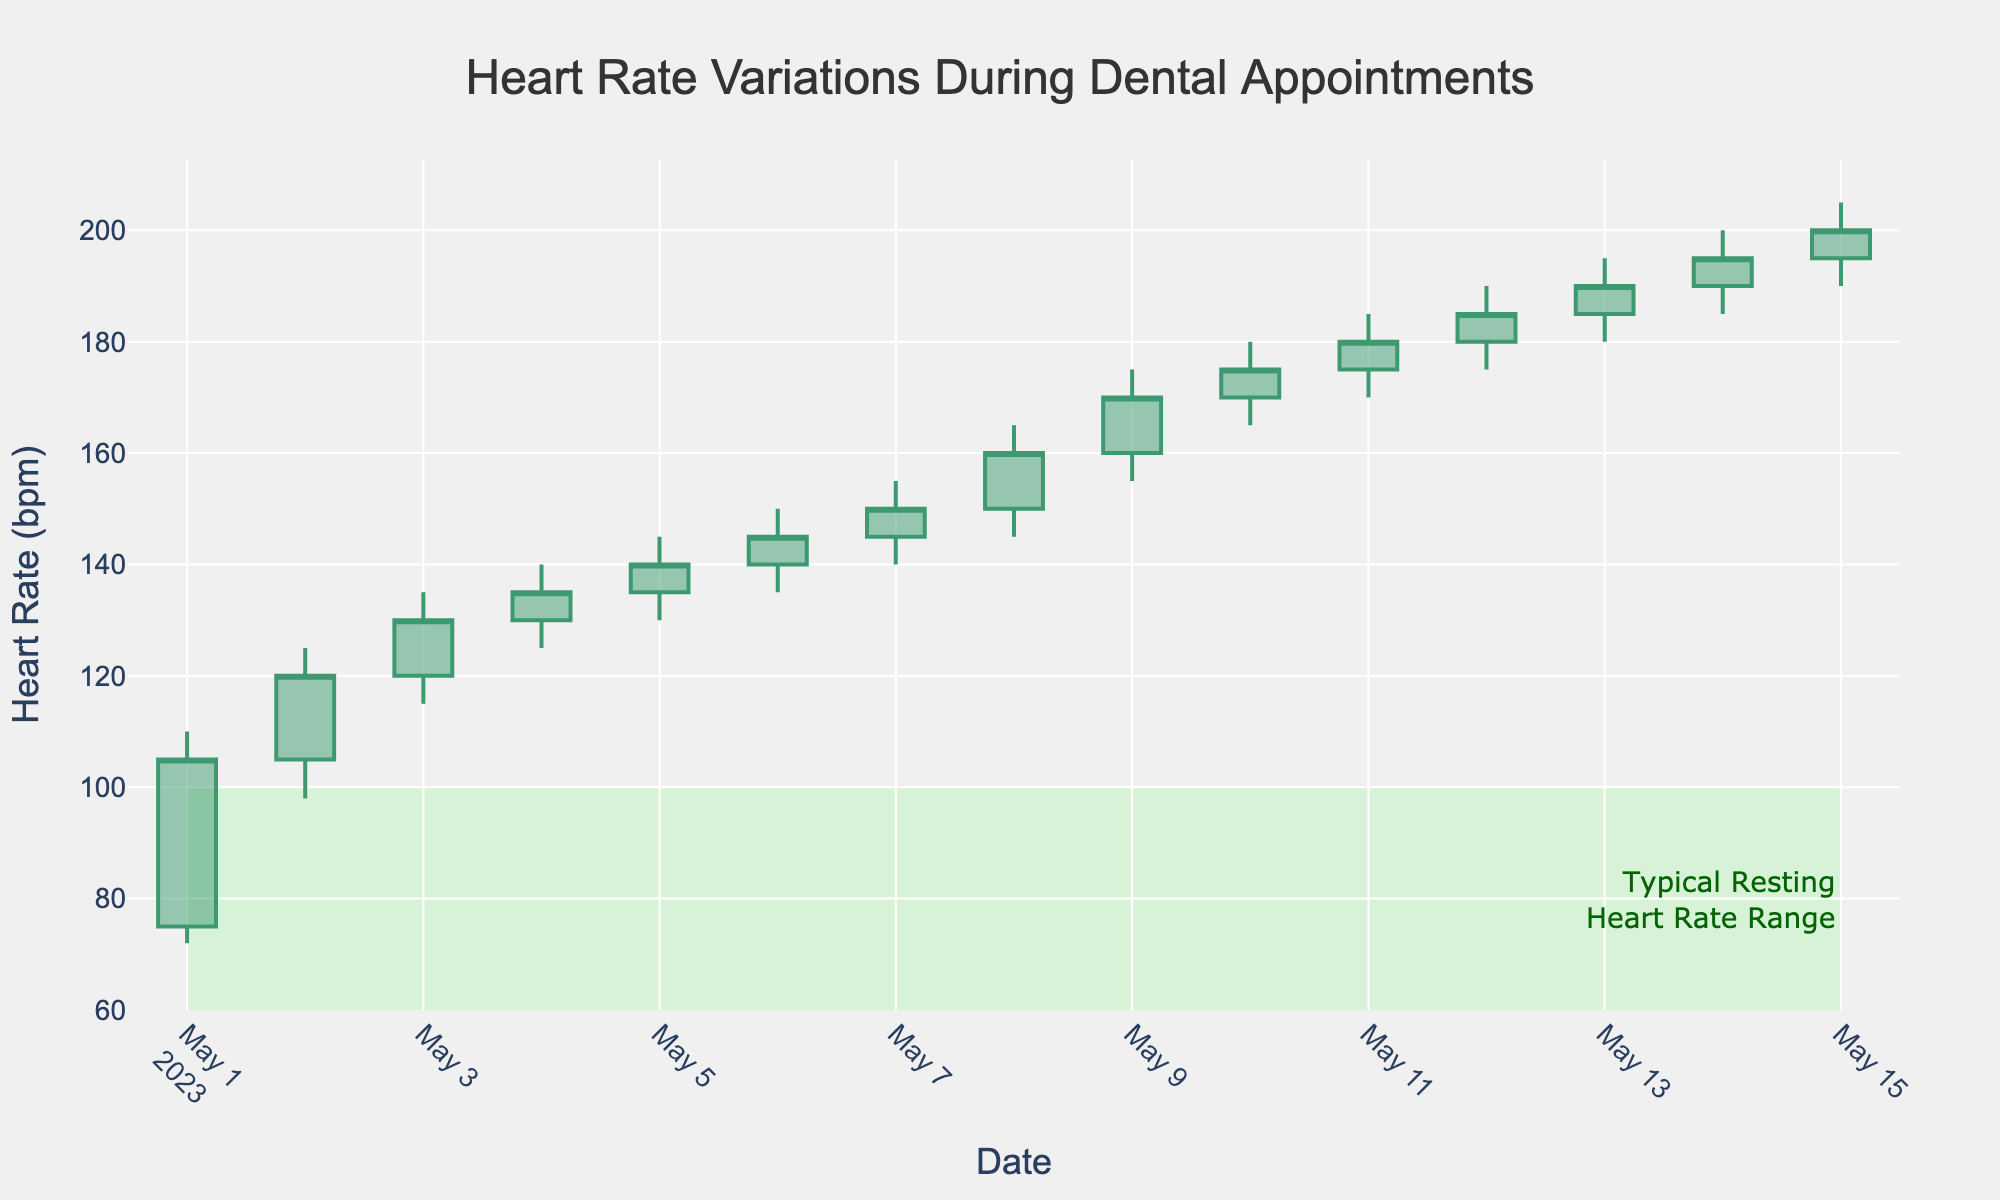What is the title of the chart? The title is prominently displayed at the top of the chart. It serves to inform the viewer of the data context.
Answer: Heart Rate Variations During Dental Appointments What is the range of dates shown on the x-axis? By examining the dates along the x-axis, we can observe the first and last dates on the chart.
Answer: 2023-05-01 to 2023-05-15 What is the highest heart rate recorded during the recorded time span? The highest point on the y-axis across all candlesticks represents the highest heart rate recorded. This appears as a peak reaching 205 bpm on 2023-05-15.
Answer: 205 bpm On which date was the patient’s heart rate first recorded above 100 bpm? By observing the candlestick data for each date, we determine the earliest date where the 'Open' value surpasses 100 bpm.
Answer: 2023-05-02 How much did the patient's heart rate rise from May 1 to May 15? First, identify the 'Open' value on 2023-05-01 (75 bpm) and the 'Close' value on 2023-05-15 (200 bpm), then calculate the difference. 200 bpm - 75 bpm equals 125 bpm.
Answer: 125 bpm Which dates mark the beginning and end of the annotated "Typical Resting Heart Rate Range"? The annotation specifies a resting heart rate range and starts on the first date and ends on the last date of the series.
Answer: 2023-05-01 to 2023-05-15 What was the lowest recorded heart rate and on what date did it occur? The lowest point on the y-axis across all candlesticks indicates the lowest recorded heart rate, observed on 2023-05-01 at 72 bpm.
Answer: 72 bpm on 2023-05-01 Which date has the smallest range between the high and low heart rate, and what is the range? Calculate the difference between 'High' and 'Low' for each day and find the day with the smallest difference. For 2023-05-01, the range 110-72=38 bpm is the smallest.
Answer: 2023-05-01, 38 bpm How many days did the patient’s heart rate stay above the resting heart rate range? Identify candlesticks where the entire candlestick (Open, Close, High, Low) stays above the 60-100 bpm range. Count the number of such days.
Answer: 15 days 